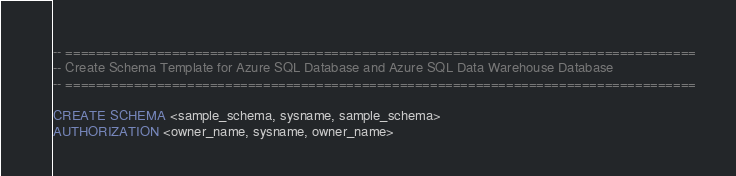Convert code to text. <code><loc_0><loc_0><loc_500><loc_500><_SQL_>-- ===================================================================================
-- Create Schema Template for Azure SQL Database and Azure SQL Data Warehouse Database
-- ===================================================================================

CREATE SCHEMA <sample_schema, sysname, sample_schema>
AUTHORIZATION <owner_name, sysname, owner_name>
</code> 